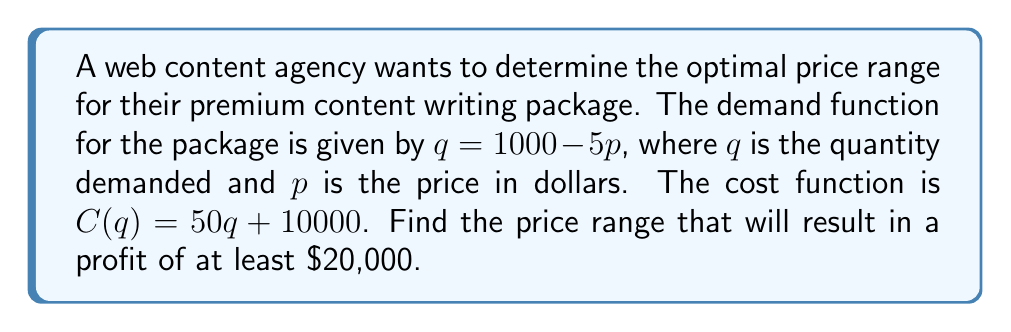Help me with this question. 1) First, let's define the profit function:
   Profit = Revenue - Cost
   $\pi = pq - C(q)$

2) Substitute the demand function and cost function:
   $\pi = p(1000 - 5p) - (50(1000 - 5p) + 10000)$

3) Expand the equation:
   $\pi = 1000p - 5p^2 - 50000 + 250p - 10000$
   $\pi = 1250p - 5p^2 - 60000$

4) We want the profit to be at least $20,000, so:
   $1250p - 5p^2 - 60000 \geq 20000$

5) Rearrange the inequality:
   $-5p^2 + 1250p - 80000 \geq 0$

6) Divide everything by -5 (remember to flip the inequality sign):
   $p^2 - 250p + 16000 \leq 0$

7) This is a quadratic inequality. We need to find the roots of the quadratic equation:
   $p^2 - 250p + 16000 = 0$

8) Using the quadratic formula: $p = \frac{-b \pm \sqrt{b^2 - 4ac}}{2a}$
   $p = \frac{250 \pm \sqrt{250^2 - 4(1)(16000)}}{2(1)}$
   $p = \frac{250 \pm \sqrt{62500 - 64000}}{2} = \frac{250 \pm \sqrt{-1500}}{2}$

9) The roots are:
   $p_1 = \frac{250 + \sqrt{1500}}{2} \approx 144.39$
   $p_2 = \frac{250 - \sqrt{1500}}{2} \approx 105.61$

10) For a quadratic inequality $\leq 0$, the solution is between the roots.

Therefore, the price range that will result in a profit of at least $20,000 is $105.61 \leq p \leq 144.39$.
Answer: $105.61 \leq p \leq 144.39$ 